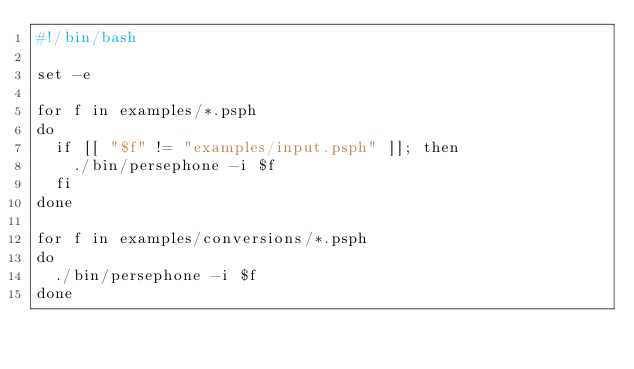<code> <loc_0><loc_0><loc_500><loc_500><_Bash_>#!/bin/bash

set -e

for f in examples/*.psph
do
  if [[ "$f" != "examples/input.psph" ]]; then
    ./bin/persephone -i $f
  fi
done

for f in examples/conversions/*.psph
do
  ./bin/persephone -i $f
done
</code> 